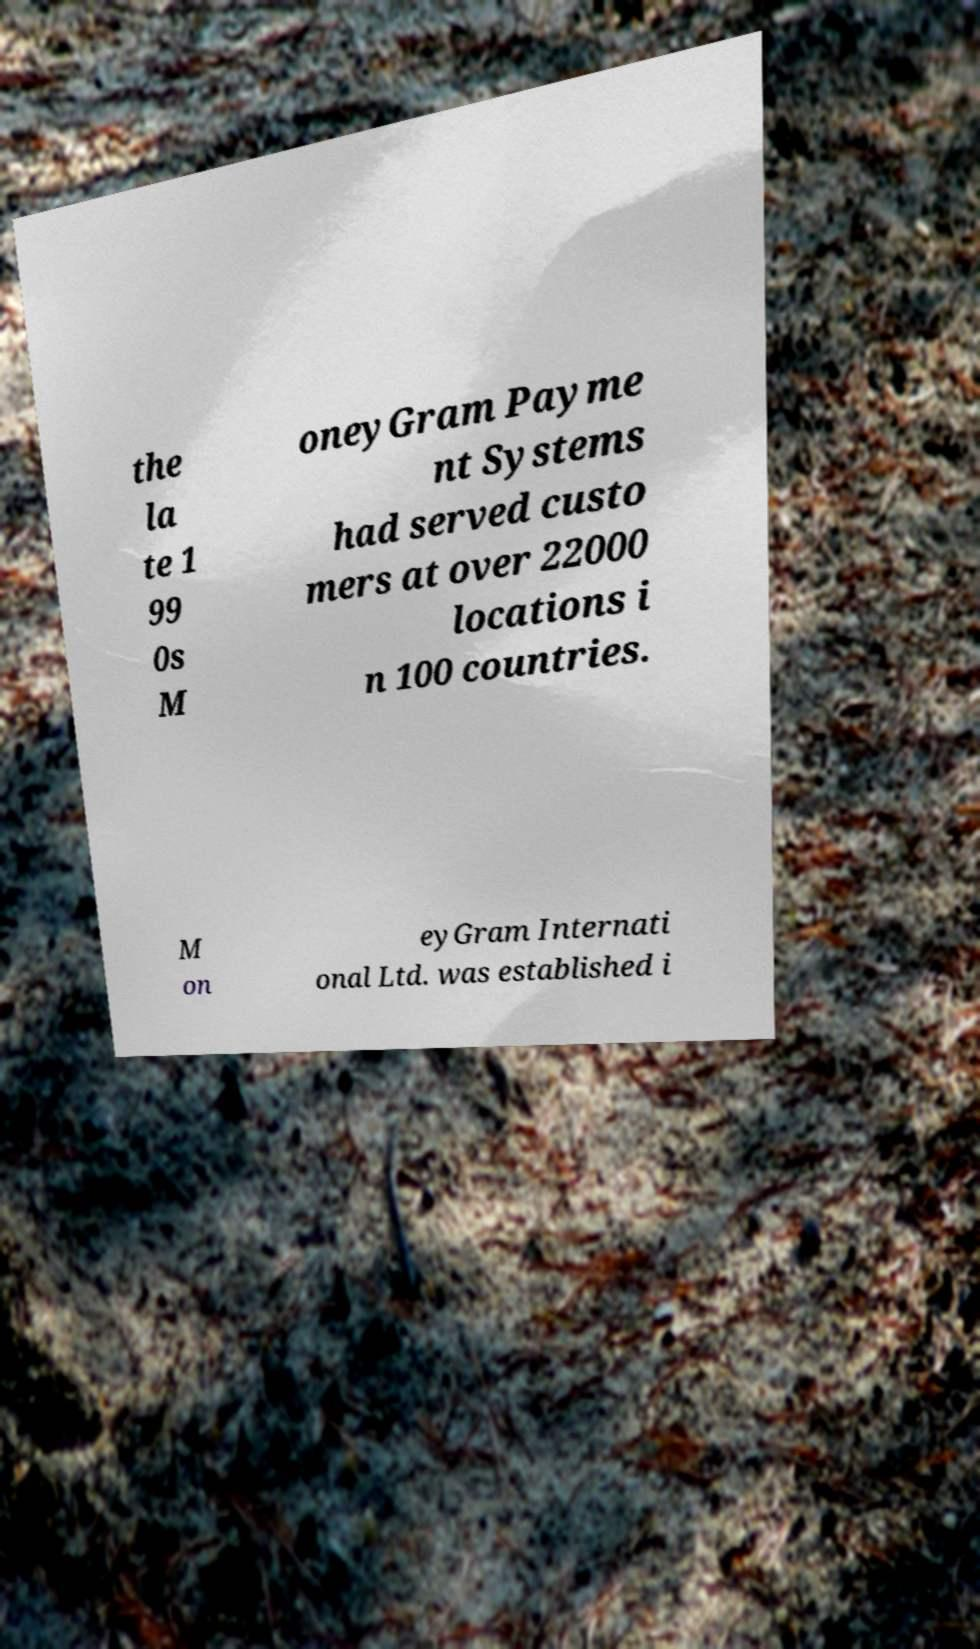Can you read and provide the text displayed in the image?This photo seems to have some interesting text. Can you extract and type it out for me? the la te 1 99 0s M oneyGram Payme nt Systems had served custo mers at over 22000 locations i n 100 countries. M on eyGram Internati onal Ltd. was established i 